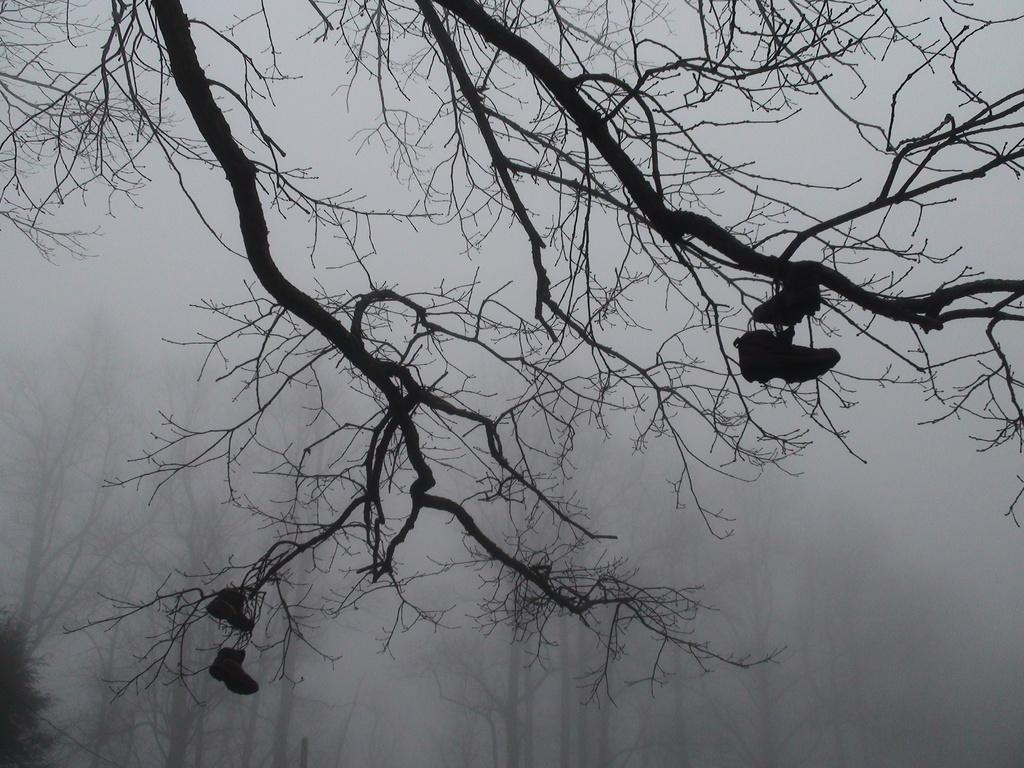What is in the foreground of the image? There are branches of a tree without leaves in the foreground of the image. What is unusual about the branches in the image? It appears that there are shoes on the branches. What can be seen in the background of the image? There are trees and fog visible in the background of the image. What type of cabbage can be seen growing on the branches in the image? There is no cabbage present in the image; it features shoes on the branches of a tree without leaves. What is the engine used for in the image? There is no engine present in the image. 